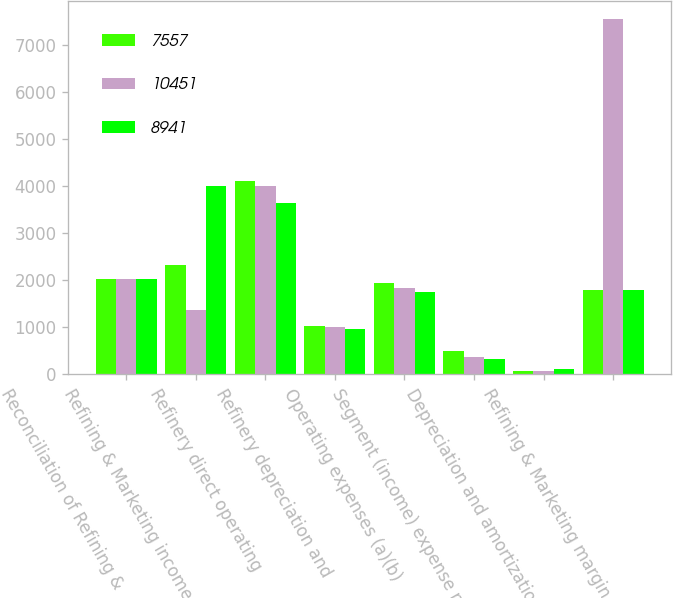Convert chart. <chart><loc_0><loc_0><loc_500><loc_500><stacked_bar_chart><ecel><fcel>Reconciliation of Refining &<fcel>Refining & Marketing income<fcel>Refinery direct operating<fcel>Refinery depreciation and<fcel>Operating expenses (a)(b)<fcel>Segment (income) expense net<fcel>Depreciation and amortization<fcel>Refining & Marketing margin<nl><fcel>7557<fcel>2017<fcel>2321<fcel>4113<fcel>1013<fcel>1924<fcel>499<fcel>69<fcel>1788.5<nl><fcel>10451<fcel>2016<fcel>1357<fcel>4007<fcel>994<fcel>1835<fcel>360<fcel>69<fcel>7557<nl><fcel>8941<fcel>2015<fcel>3997<fcel>3640<fcel>955<fcel>1742<fcel>325<fcel>97<fcel>1788.5<nl></chart> 